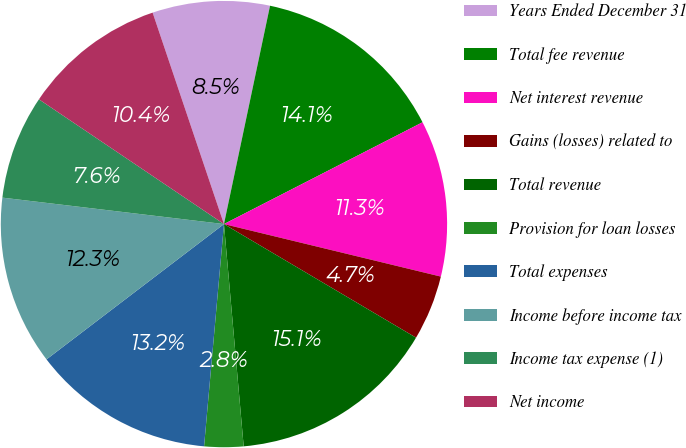<chart> <loc_0><loc_0><loc_500><loc_500><pie_chart><fcel>Years Ended December 31<fcel>Total fee revenue<fcel>Net interest revenue<fcel>Gains (losses) related to<fcel>Total revenue<fcel>Provision for loan losses<fcel>Total expenses<fcel>Income before income tax<fcel>Income tax expense (1)<fcel>Net income<nl><fcel>8.49%<fcel>14.15%<fcel>11.32%<fcel>4.72%<fcel>15.09%<fcel>2.83%<fcel>13.21%<fcel>12.26%<fcel>7.55%<fcel>10.38%<nl></chart> 